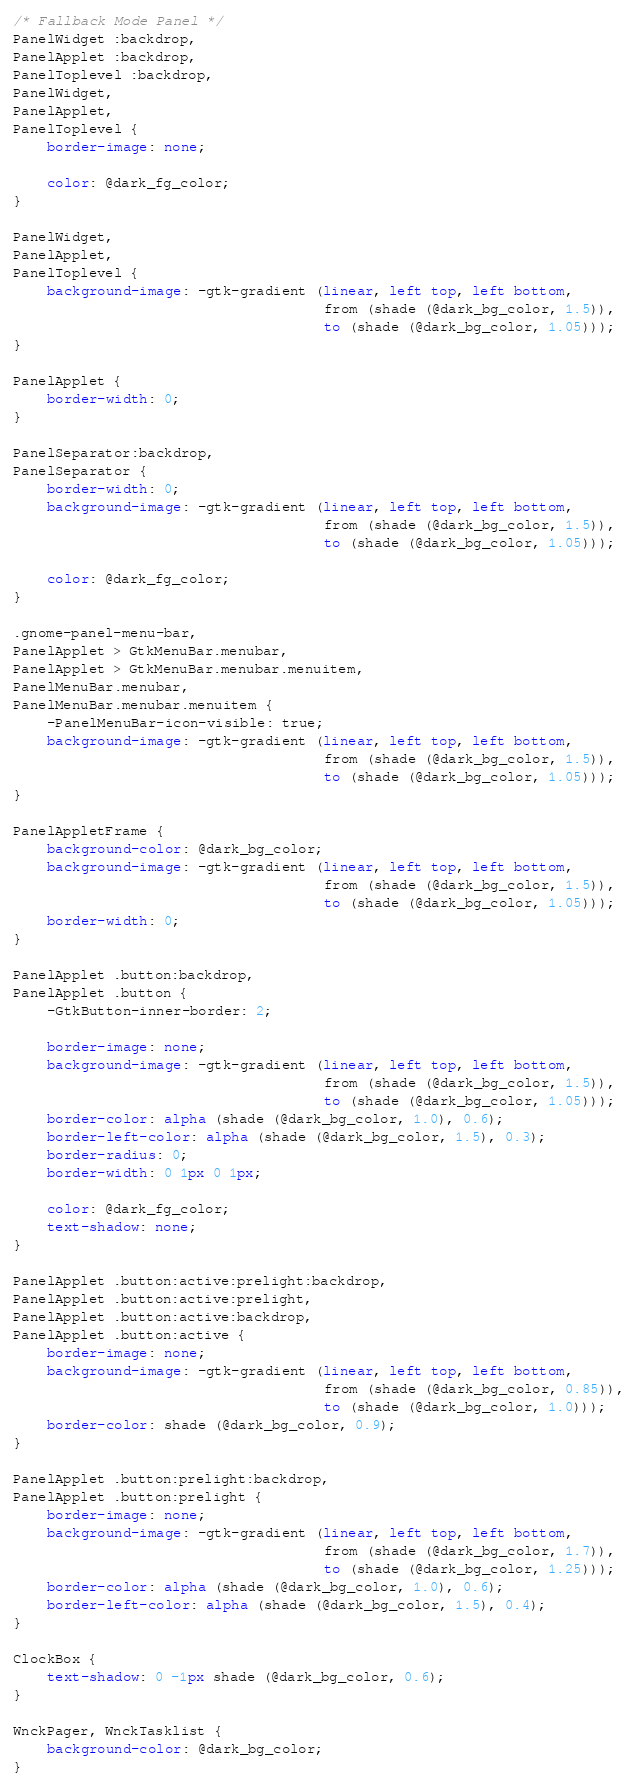Convert code to text. <code><loc_0><loc_0><loc_500><loc_500><_CSS_>/* Fallback Mode Panel */
PanelWidget :backdrop,
PanelApplet :backdrop,
PanelToplevel :backdrop,
PanelWidget,
PanelApplet,
PanelToplevel {
    border-image: none;

    color: @dark_fg_color;
}

PanelWidget,
PanelApplet,
PanelToplevel {
    background-image: -gtk-gradient (linear, left top, left bottom,
                                     from (shade (@dark_bg_color, 1.5)),
                                     to (shade (@dark_bg_color, 1.05)));
}

PanelApplet {
    border-width: 0;
}

PanelSeparator:backdrop,
PanelSeparator {
    border-width: 0;
    background-image: -gtk-gradient (linear, left top, left bottom,
                                     from (shade (@dark_bg_color, 1.5)),
                                     to (shade (@dark_bg_color, 1.05)));

    color: @dark_fg_color;
}

.gnome-panel-menu-bar,
PanelApplet > GtkMenuBar.menubar,
PanelApplet > GtkMenuBar.menubar.menuitem,
PanelMenuBar.menubar,
PanelMenuBar.menubar.menuitem {
    -PanelMenuBar-icon-visible: true;
    background-image: -gtk-gradient (linear, left top, left bottom,
                                     from (shade (@dark_bg_color, 1.5)),
                                     to (shade (@dark_bg_color, 1.05)));
}

PanelAppletFrame { 
    background-color: @dark_bg_color;
    background-image: -gtk-gradient (linear, left top, left bottom,
                                     from (shade (@dark_bg_color, 1.5)),
                                     to (shade (@dark_bg_color, 1.05)));
    border-width: 0;
}

PanelApplet .button:backdrop,
PanelApplet .button {
    -GtkButton-inner-border: 2;

    border-image: none;
    background-image: -gtk-gradient (linear, left top, left bottom,
                                     from (shade (@dark_bg_color, 1.5)),
                                     to (shade (@dark_bg_color, 1.05)));
    border-color: alpha (shade (@dark_bg_color, 1.0), 0.6);
    border-left-color: alpha (shade (@dark_bg_color, 1.5), 0.3);
    border-radius: 0;
    border-width: 0 1px 0 1px;

    color: @dark_fg_color;
    text-shadow: none;
}

PanelApplet .button:active:prelight:backdrop,
PanelApplet .button:active:prelight,
PanelApplet .button:active:backdrop,
PanelApplet .button:active {
    border-image: none;
    background-image: -gtk-gradient (linear, left top, left bottom,
                                     from (shade (@dark_bg_color, 0.85)),
                                     to (shade (@dark_bg_color, 1.0))); 
    border-color: shade (@dark_bg_color, 0.9);
}

PanelApplet .button:prelight:backdrop,
PanelApplet .button:prelight {
    border-image: none;
    background-image: -gtk-gradient (linear, left top, left bottom,
                                     from (shade (@dark_bg_color, 1.7)),
                                     to (shade (@dark_bg_color, 1.25)));
    border-color: alpha (shade (@dark_bg_color, 1.0), 0.6);
    border-left-color: alpha (shade (@dark_bg_color, 1.5), 0.4);
}

ClockBox {
    text-shadow: 0 -1px shade (@dark_bg_color, 0.6);
}

WnckPager, WnckTasklist {
    background-color: @dark_bg_color;
}
</code> 